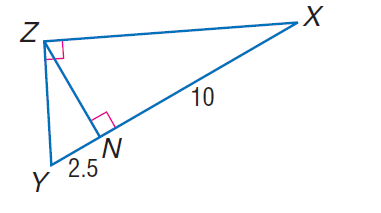Answer the mathemtical geometry problem and directly provide the correct option letter.
Question: Find the measure of the altitude drawn to the hypotenuse.
Choices: A: \sqrt { 2.5 } B: 2 C: \sqrt { 10 } D: 5 D 